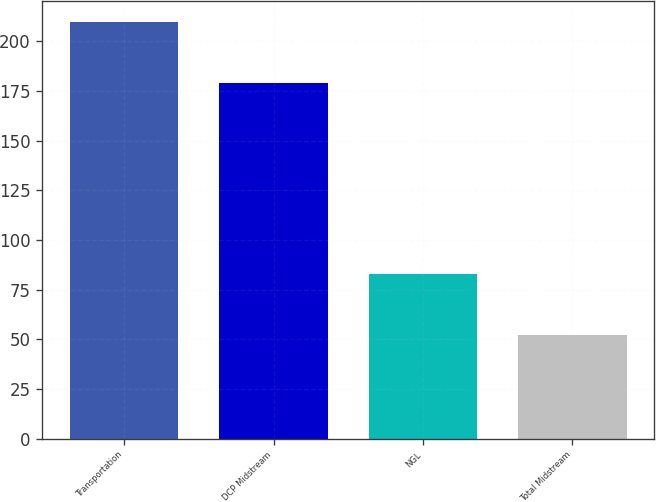Convert chart. <chart><loc_0><loc_0><loc_500><loc_500><bar_chart><fcel>Transportation<fcel>DCP Midstream<fcel>NGL<fcel>Total Midstream<nl><fcel>210<fcel>179<fcel>83<fcel>52<nl></chart> 